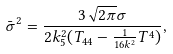Convert formula to latex. <formula><loc_0><loc_0><loc_500><loc_500>\bar { \sigma } ^ { 2 } = \frac { 3 \sqrt { 2 \pi } \sigma } { 2 k _ { 5 } ^ { 2 } ( T _ { 4 4 } - \frac { 1 } { 1 6 k ^ { 2 } } T ^ { 4 } ) } ,</formula> 